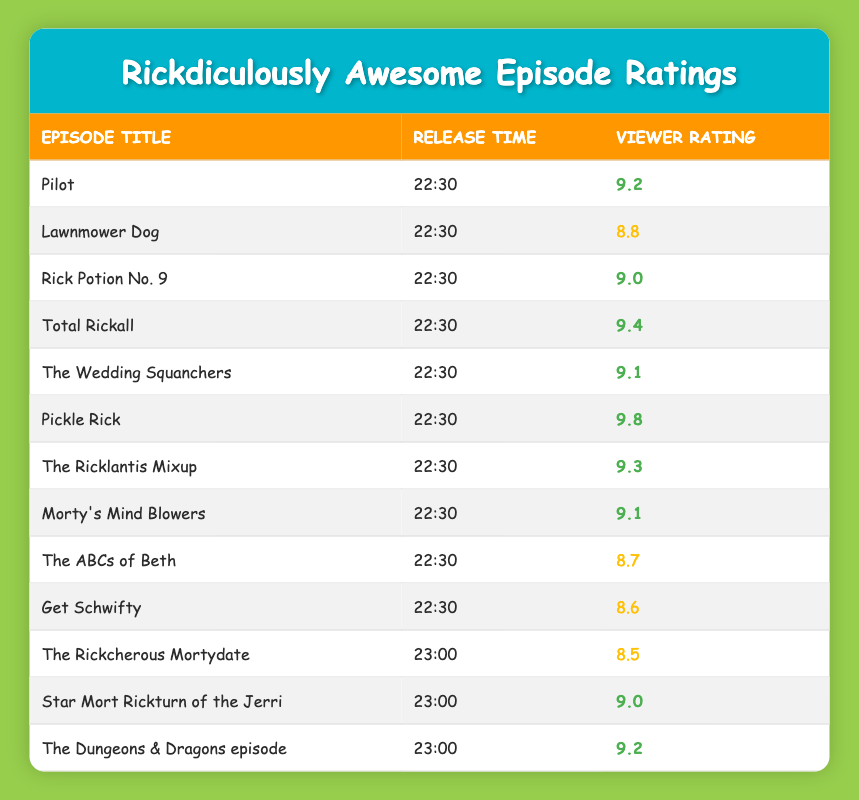What is the viewer rating for the episode "Pickle Rick"? The table shows that the viewer rating for "Pickle Rick" is listed under the "Viewer Rating" column, which directly states the value 9.8.
Answer: 9.8 How many episodes have a viewer rating above 9.0 that were released at 22:30? The table lists several episodes at the 22:30 release time. The episodes with ratings above 9.0 are: "Pilot" (9.2), "Rick Potion No. 9" (9.0), "Total Rickall" (9.4), "The Wedding Squanchers" (9.1), "Pickle Rick" (9.8), "The Ricklantis Mixup" (9.3), and "Morty's Mind Blowers" (9.1). Counting these, there are 6 episodes with ratings above 9.0.
Answer: 6 Is "The Rickcherous Mortydate" rated higher than "Lawnmower Dog"? "The Rickcherous Mortydate" has a rating of 8.5, while "Lawnmower Dog" has a rating of 8.8. Since 8.5 is less than 8.8, the statement is false.
Answer: No What is the average viewer rating for the episodes aired at 23:00? The viewer ratings for the three episodes at 23:00 are 8.5 (The Rickcherous Mortydate), 9.0 (Star Mort Rickturn of the Jerri), and 9.2 (The Dungeons & Dragons episode). The sum is 8.5 + 9.0 + 9.2 = 26.7. To find the average, we divide by the number of episodes (3), so 26.7 / 3 = 8.9.
Answer: 8.9 Which episode released at 23:00 has the highest rating? By examining the ratings of the episodes released at 23:00, we see that "The Dungeons & Dragons episode" has a rating of 9.2, which is the highest compared to the other two episodes (8.5 and 9.0).
Answer: The Dungeons & Dragons episode How many episodes released at 22:30 have a viewer rating of 9.0 or higher? The episodes at 22:30 with ratings of 9.0 or higher are: "Pilot" (9.2), "Total Rickall" (9.4), "The Wedding Squanchers" (9.1), "Pickle Rick" (9.8), "The Ricklantis Mixup" (9.3), and "Morty's Mind Blowers" (9.1), totaling 6 episodes.
Answer: 6 